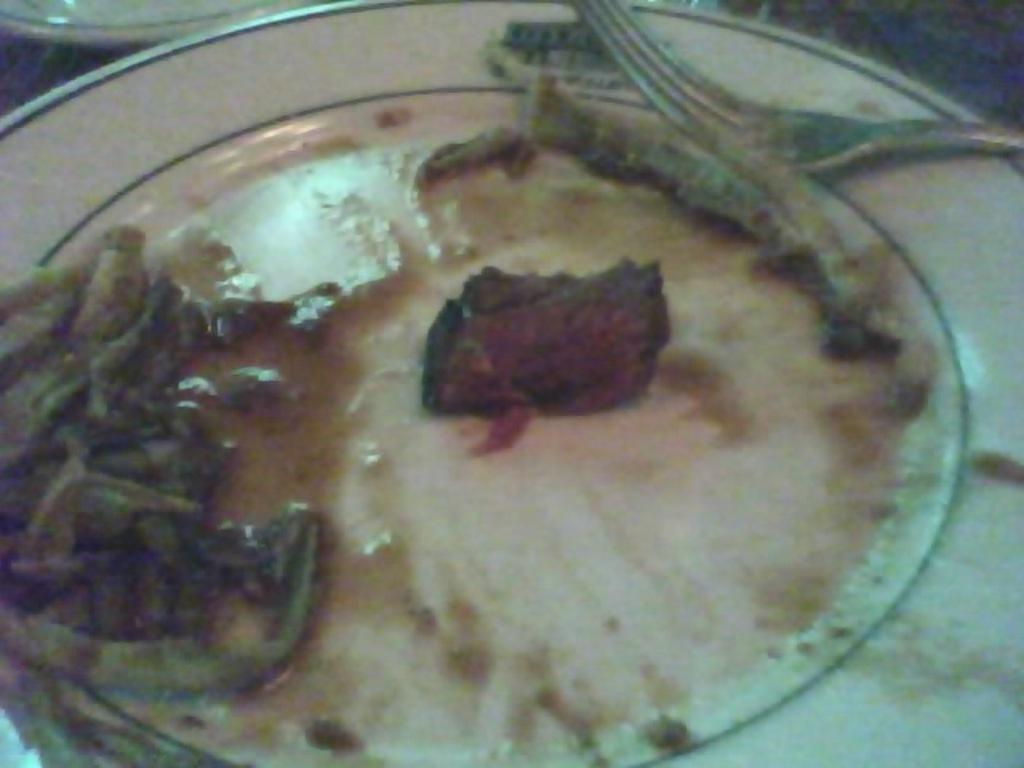What is the color of the plate that holds the food item in the image? The plate is white. What colors can be seen in the food item? The food has red and brown colors. What utensil is visible in the image? There is a fork visible in the image. What is the current condition of the food processing industry in the image? There is no information about the food processing industry in the image, as it only shows a food item on a plate with a fork. 